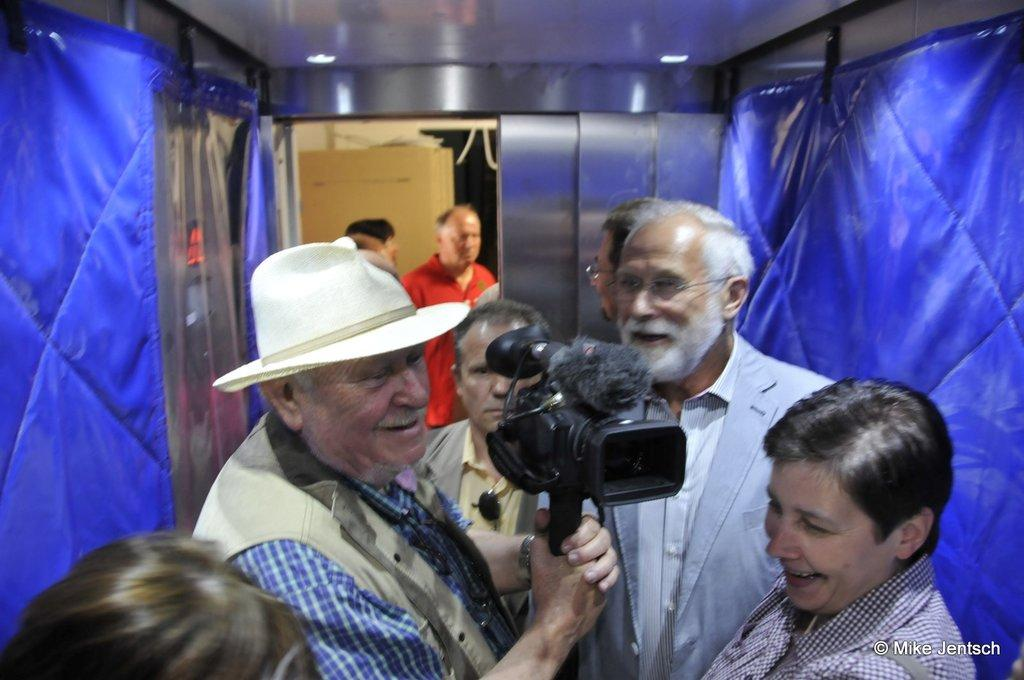What is the setting of the image? The image is inside a room. How many people are in the image? There are multiple people in the image. What is the facial expression of the people in the image? All the people are smiling. Can you describe the clothing and accessories of one person in the image? One person is wearing a blue check shirt, a coat, and a white hat, and is holding a camera. What color are the walls in the room? The walls in the room are blue. What type of pies are being served on the side in the image? There is no mention of pies or any food being served in the image. 